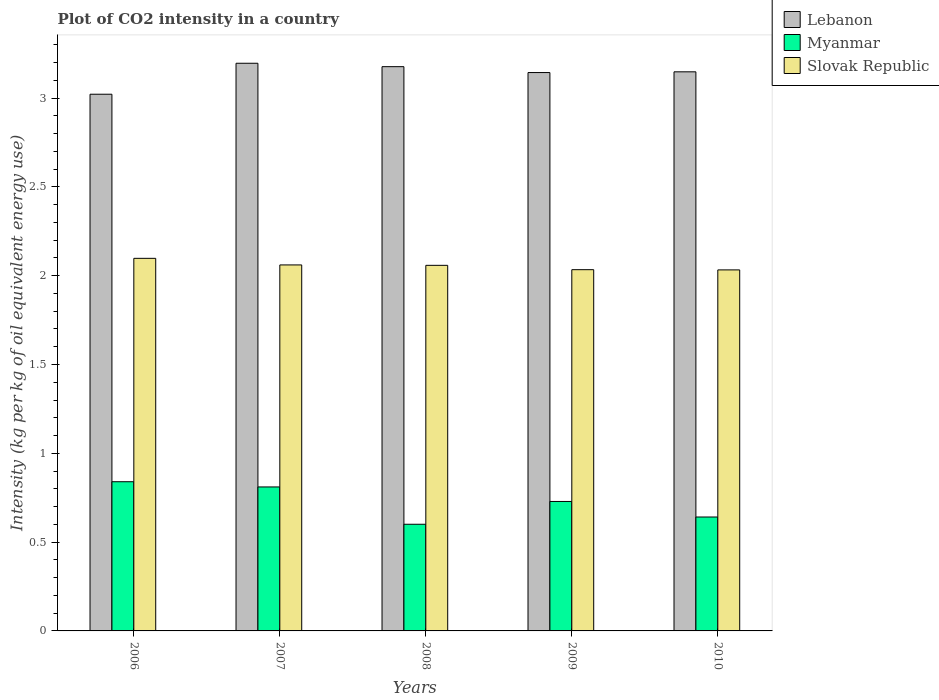How many different coloured bars are there?
Make the answer very short. 3. How many groups of bars are there?
Make the answer very short. 5. Are the number of bars per tick equal to the number of legend labels?
Offer a very short reply. Yes. How many bars are there on the 2nd tick from the left?
Ensure brevity in your answer.  3. How many bars are there on the 5th tick from the right?
Ensure brevity in your answer.  3. What is the label of the 5th group of bars from the left?
Make the answer very short. 2010. What is the CO2 intensity in in Slovak Republic in 2010?
Ensure brevity in your answer.  2.03. Across all years, what is the maximum CO2 intensity in in Slovak Republic?
Keep it short and to the point. 2.1. Across all years, what is the minimum CO2 intensity in in Slovak Republic?
Offer a very short reply. 2.03. What is the total CO2 intensity in in Slovak Republic in the graph?
Ensure brevity in your answer.  10.28. What is the difference between the CO2 intensity in in Slovak Republic in 2006 and that in 2008?
Offer a terse response. 0.04. What is the difference between the CO2 intensity in in Slovak Republic in 2008 and the CO2 intensity in in Lebanon in 2010?
Make the answer very short. -1.09. What is the average CO2 intensity in in Myanmar per year?
Make the answer very short. 0.72. In the year 2009, what is the difference between the CO2 intensity in in Myanmar and CO2 intensity in in Slovak Republic?
Make the answer very short. -1.31. What is the ratio of the CO2 intensity in in Myanmar in 2006 to that in 2008?
Ensure brevity in your answer.  1.4. Is the CO2 intensity in in Lebanon in 2006 less than that in 2009?
Give a very brief answer. Yes. Is the difference between the CO2 intensity in in Myanmar in 2009 and 2010 greater than the difference between the CO2 intensity in in Slovak Republic in 2009 and 2010?
Your answer should be very brief. Yes. What is the difference between the highest and the second highest CO2 intensity in in Lebanon?
Your answer should be very brief. 0.02. What is the difference between the highest and the lowest CO2 intensity in in Myanmar?
Make the answer very short. 0.24. In how many years, is the CO2 intensity in in Slovak Republic greater than the average CO2 intensity in in Slovak Republic taken over all years?
Your response must be concise. 3. Is the sum of the CO2 intensity in in Myanmar in 2006 and 2008 greater than the maximum CO2 intensity in in Lebanon across all years?
Your response must be concise. No. What does the 3rd bar from the left in 2006 represents?
Make the answer very short. Slovak Republic. What does the 2nd bar from the right in 2010 represents?
Your response must be concise. Myanmar. Is it the case that in every year, the sum of the CO2 intensity in in Myanmar and CO2 intensity in in Slovak Republic is greater than the CO2 intensity in in Lebanon?
Ensure brevity in your answer.  No. Are all the bars in the graph horizontal?
Offer a very short reply. No. How many years are there in the graph?
Your answer should be compact. 5. What is the difference between two consecutive major ticks on the Y-axis?
Provide a short and direct response. 0.5. How many legend labels are there?
Your response must be concise. 3. What is the title of the graph?
Ensure brevity in your answer.  Plot of CO2 intensity in a country. What is the label or title of the Y-axis?
Keep it short and to the point. Intensity (kg per kg of oil equivalent energy use). What is the Intensity (kg per kg of oil equivalent energy use) in Lebanon in 2006?
Make the answer very short. 3.02. What is the Intensity (kg per kg of oil equivalent energy use) of Myanmar in 2006?
Your response must be concise. 0.84. What is the Intensity (kg per kg of oil equivalent energy use) in Slovak Republic in 2006?
Offer a terse response. 2.1. What is the Intensity (kg per kg of oil equivalent energy use) in Lebanon in 2007?
Ensure brevity in your answer.  3.2. What is the Intensity (kg per kg of oil equivalent energy use) in Myanmar in 2007?
Offer a very short reply. 0.81. What is the Intensity (kg per kg of oil equivalent energy use) of Slovak Republic in 2007?
Offer a terse response. 2.06. What is the Intensity (kg per kg of oil equivalent energy use) of Lebanon in 2008?
Your answer should be compact. 3.18. What is the Intensity (kg per kg of oil equivalent energy use) in Myanmar in 2008?
Your response must be concise. 0.6. What is the Intensity (kg per kg of oil equivalent energy use) of Slovak Republic in 2008?
Provide a short and direct response. 2.06. What is the Intensity (kg per kg of oil equivalent energy use) of Lebanon in 2009?
Give a very brief answer. 3.14. What is the Intensity (kg per kg of oil equivalent energy use) of Myanmar in 2009?
Your response must be concise. 0.73. What is the Intensity (kg per kg of oil equivalent energy use) in Slovak Republic in 2009?
Give a very brief answer. 2.03. What is the Intensity (kg per kg of oil equivalent energy use) in Lebanon in 2010?
Provide a short and direct response. 3.15. What is the Intensity (kg per kg of oil equivalent energy use) in Myanmar in 2010?
Ensure brevity in your answer.  0.64. What is the Intensity (kg per kg of oil equivalent energy use) of Slovak Republic in 2010?
Your answer should be compact. 2.03. Across all years, what is the maximum Intensity (kg per kg of oil equivalent energy use) in Lebanon?
Ensure brevity in your answer.  3.2. Across all years, what is the maximum Intensity (kg per kg of oil equivalent energy use) in Myanmar?
Provide a succinct answer. 0.84. Across all years, what is the maximum Intensity (kg per kg of oil equivalent energy use) of Slovak Republic?
Provide a succinct answer. 2.1. Across all years, what is the minimum Intensity (kg per kg of oil equivalent energy use) of Lebanon?
Make the answer very short. 3.02. Across all years, what is the minimum Intensity (kg per kg of oil equivalent energy use) of Myanmar?
Keep it short and to the point. 0.6. Across all years, what is the minimum Intensity (kg per kg of oil equivalent energy use) in Slovak Republic?
Make the answer very short. 2.03. What is the total Intensity (kg per kg of oil equivalent energy use) in Lebanon in the graph?
Offer a very short reply. 15.69. What is the total Intensity (kg per kg of oil equivalent energy use) in Myanmar in the graph?
Offer a very short reply. 3.62. What is the total Intensity (kg per kg of oil equivalent energy use) of Slovak Republic in the graph?
Your answer should be very brief. 10.28. What is the difference between the Intensity (kg per kg of oil equivalent energy use) in Lebanon in 2006 and that in 2007?
Provide a succinct answer. -0.17. What is the difference between the Intensity (kg per kg of oil equivalent energy use) in Myanmar in 2006 and that in 2007?
Make the answer very short. 0.03. What is the difference between the Intensity (kg per kg of oil equivalent energy use) of Slovak Republic in 2006 and that in 2007?
Your answer should be very brief. 0.04. What is the difference between the Intensity (kg per kg of oil equivalent energy use) of Lebanon in 2006 and that in 2008?
Your answer should be compact. -0.16. What is the difference between the Intensity (kg per kg of oil equivalent energy use) in Myanmar in 2006 and that in 2008?
Make the answer very short. 0.24. What is the difference between the Intensity (kg per kg of oil equivalent energy use) of Slovak Republic in 2006 and that in 2008?
Offer a very short reply. 0.04. What is the difference between the Intensity (kg per kg of oil equivalent energy use) in Lebanon in 2006 and that in 2009?
Your response must be concise. -0.12. What is the difference between the Intensity (kg per kg of oil equivalent energy use) of Slovak Republic in 2006 and that in 2009?
Offer a terse response. 0.06. What is the difference between the Intensity (kg per kg of oil equivalent energy use) in Lebanon in 2006 and that in 2010?
Make the answer very short. -0.13. What is the difference between the Intensity (kg per kg of oil equivalent energy use) of Myanmar in 2006 and that in 2010?
Your response must be concise. 0.2. What is the difference between the Intensity (kg per kg of oil equivalent energy use) in Slovak Republic in 2006 and that in 2010?
Offer a very short reply. 0.07. What is the difference between the Intensity (kg per kg of oil equivalent energy use) in Lebanon in 2007 and that in 2008?
Offer a terse response. 0.02. What is the difference between the Intensity (kg per kg of oil equivalent energy use) in Myanmar in 2007 and that in 2008?
Your response must be concise. 0.21. What is the difference between the Intensity (kg per kg of oil equivalent energy use) of Slovak Republic in 2007 and that in 2008?
Make the answer very short. 0. What is the difference between the Intensity (kg per kg of oil equivalent energy use) of Lebanon in 2007 and that in 2009?
Keep it short and to the point. 0.05. What is the difference between the Intensity (kg per kg of oil equivalent energy use) of Myanmar in 2007 and that in 2009?
Make the answer very short. 0.08. What is the difference between the Intensity (kg per kg of oil equivalent energy use) of Slovak Republic in 2007 and that in 2009?
Offer a very short reply. 0.03. What is the difference between the Intensity (kg per kg of oil equivalent energy use) of Lebanon in 2007 and that in 2010?
Provide a succinct answer. 0.05. What is the difference between the Intensity (kg per kg of oil equivalent energy use) of Myanmar in 2007 and that in 2010?
Provide a succinct answer. 0.17. What is the difference between the Intensity (kg per kg of oil equivalent energy use) of Slovak Republic in 2007 and that in 2010?
Offer a very short reply. 0.03. What is the difference between the Intensity (kg per kg of oil equivalent energy use) in Lebanon in 2008 and that in 2009?
Offer a very short reply. 0.03. What is the difference between the Intensity (kg per kg of oil equivalent energy use) of Myanmar in 2008 and that in 2009?
Provide a short and direct response. -0.13. What is the difference between the Intensity (kg per kg of oil equivalent energy use) of Slovak Republic in 2008 and that in 2009?
Your response must be concise. 0.02. What is the difference between the Intensity (kg per kg of oil equivalent energy use) in Lebanon in 2008 and that in 2010?
Your answer should be very brief. 0.03. What is the difference between the Intensity (kg per kg of oil equivalent energy use) of Myanmar in 2008 and that in 2010?
Keep it short and to the point. -0.04. What is the difference between the Intensity (kg per kg of oil equivalent energy use) of Slovak Republic in 2008 and that in 2010?
Offer a very short reply. 0.03. What is the difference between the Intensity (kg per kg of oil equivalent energy use) in Lebanon in 2009 and that in 2010?
Your answer should be compact. -0. What is the difference between the Intensity (kg per kg of oil equivalent energy use) in Myanmar in 2009 and that in 2010?
Provide a short and direct response. 0.09. What is the difference between the Intensity (kg per kg of oil equivalent energy use) of Slovak Republic in 2009 and that in 2010?
Your answer should be compact. 0. What is the difference between the Intensity (kg per kg of oil equivalent energy use) of Lebanon in 2006 and the Intensity (kg per kg of oil equivalent energy use) of Myanmar in 2007?
Give a very brief answer. 2.21. What is the difference between the Intensity (kg per kg of oil equivalent energy use) of Lebanon in 2006 and the Intensity (kg per kg of oil equivalent energy use) of Slovak Republic in 2007?
Give a very brief answer. 0.96. What is the difference between the Intensity (kg per kg of oil equivalent energy use) in Myanmar in 2006 and the Intensity (kg per kg of oil equivalent energy use) in Slovak Republic in 2007?
Provide a short and direct response. -1.22. What is the difference between the Intensity (kg per kg of oil equivalent energy use) of Lebanon in 2006 and the Intensity (kg per kg of oil equivalent energy use) of Myanmar in 2008?
Your answer should be very brief. 2.42. What is the difference between the Intensity (kg per kg of oil equivalent energy use) in Lebanon in 2006 and the Intensity (kg per kg of oil equivalent energy use) in Slovak Republic in 2008?
Your response must be concise. 0.96. What is the difference between the Intensity (kg per kg of oil equivalent energy use) of Myanmar in 2006 and the Intensity (kg per kg of oil equivalent energy use) of Slovak Republic in 2008?
Your answer should be compact. -1.22. What is the difference between the Intensity (kg per kg of oil equivalent energy use) of Lebanon in 2006 and the Intensity (kg per kg of oil equivalent energy use) of Myanmar in 2009?
Your answer should be very brief. 2.29. What is the difference between the Intensity (kg per kg of oil equivalent energy use) in Lebanon in 2006 and the Intensity (kg per kg of oil equivalent energy use) in Slovak Republic in 2009?
Your response must be concise. 0.99. What is the difference between the Intensity (kg per kg of oil equivalent energy use) in Myanmar in 2006 and the Intensity (kg per kg of oil equivalent energy use) in Slovak Republic in 2009?
Offer a very short reply. -1.19. What is the difference between the Intensity (kg per kg of oil equivalent energy use) in Lebanon in 2006 and the Intensity (kg per kg of oil equivalent energy use) in Myanmar in 2010?
Make the answer very short. 2.38. What is the difference between the Intensity (kg per kg of oil equivalent energy use) in Myanmar in 2006 and the Intensity (kg per kg of oil equivalent energy use) in Slovak Republic in 2010?
Provide a short and direct response. -1.19. What is the difference between the Intensity (kg per kg of oil equivalent energy use) of Lebanon in 2007 and the Intensity (kg per kg of oil equivalent energy use) of Myanmar in 2008?
Offer a very short reply. 2.6. What is the difference between the Intensity (kg per kg of oil equivalent energy use) in Lebanon in 2007 and the Intensity (kg per kg of oil equivalent energy use) in Slovak Republic in 2008?
Make the answer very short. 1.14. What is the difference between the Intensity (kg per kg of oil equivalent energy use) of Myanmar in 2007 and the Intensity (kg per kg of oil equivalent energy use) of Slovak Republic in 2008?
Ensure brevity in your answer.  -1.25. What is the difference between the Intensity (kg per kg of oil equivalent energy use) in Lebanon in 2007 and the Intensity (kg per kg of oil equivalent energy use) in Myanmar in 2009?
Offer a terse response. 2.47. What is the difference between the Intensity (kg per kg of oil equivalent energy use) of Lebanon in 2007 and the Intensity (kg per kg of oil equivalent energy use) of Slovak Republic in 2009?
Provide a short and direct response. 1.16. What is the difference between the Intensity (kg per kg of oil equivalent energy use) of Myanmar in 2007 and the Intensity (kg per kg of oil equivalent energy use) of Slovak Republic in 2009?
Give a very brief answer. -1.22. What is the difference between the Intensity (kg per kg of oil equivalent energy use) of Lebanon in 2007 and the Intensity (kg per kg of oil equivalent energy use) of Myanmar in 2010?
Provide a short and direct response. 2.55. What is the difference between the Intensity (kg per kg of oil equivalent energy use) in Lebanon in 2007 and the Intensity (kg per kg of oil equivalent energy use) in Slovak Republic in 2010?
Your answer should be very brief. 1.16. What is the difference between the Intensity (kg per kg of oil equivalent energy use) of Myanmar in 2007 and the Intensity (kg per kg of oil equivalent energy use) of Slovak Republic in 2010?
Provide a succinct answer. -1.22. What is the difference between the Intensity (kg per kg of oil equivalent energy use) of Lebanon in 2008 and the Intensity (kg per kg of oil equivalent energy use) of Myanmar in 2009?
Offer a terse response. 2.45. What is the difference between the Intensity (kg per kg of oil equivalent energy use) of Lebanon in 2008 and the Intensity (kg per kg of oil equivalent energy use) of Slovak Republic in 2009?
Keep it short and to the point. 1.14. What is the difference between the Intensity (kg per kg of oil equivalent energy use) of Myanmar in 2008 and the Intensity (kg per kg of oil equivalent energy use) of Slovak Republic in 2009?
Provide a short and direct response. -1.43. What is the difference between the Intensity (kg per kg of oil equivalent energy use) of Lebanon in 2008 and the Intensity (kg per kg of oil equivalent energy use) of Myanmar in 2010?
Your answer should be compact. 2.54. What is the difference between the Intensity (kg per kg of oil equivalent energy use) of Lebanon in 2008 and the Intensity (kg per kg of oil equivalent energy use) of Slovak Republic in 2010?
Make the answer very short. 1.14. What is the difference between the Intensity (kg per kg of oil equivalent energy use) in Myanmar in 2008 and the Intensity (kg per kg of oil equivalent energy use) in Slovak Republic in 2010?
Your answer should be compact. -1.43. What is the difference between the Intensity (kg per kg of oil equivalent energy use) in Lebanon in 2009 and the Intensity (kg per kg of oil equivalent energy use) in Myanmar in 2010?
Offer a very short reply. 2.5. What is the difference between the Intensity (kg per kg of oil equivalent energy use) in Lebanon in 2009 and the Intensity (kg per kg of oil equivalent energy use) in Slovak Republic in 2010?
Your response must be concise. 1.11. What is the difference between the Intensity (kg per kg of oil equivalent energy use) in Myanmar in 2009 and the Intensity (kg per kg of oil equivalent energy use) in Slovak Republic in 2010?
Ensure brevity in your answer.  -1.3. What is the average Intensity (kg per kg of oil equivalent energy use) in Lebanon per year?
Keep it short and to the point. 3.14. What is the average Intensity (kg per kg of oil equivalent energy use) in Myanmar per year?
Make the answer very short. 0.72. What is the average Intensity (kg per kg of oil equivalent energy use) in Slovak Republic per year?
Keep it short and to the point. 2.06. In the year 2006, what is the difference between the Intensity (kg per kg of oil equivalent energy use) in Lebanon and Intensity (kg per kg of oil equivalent energy use) in Myanmar?
Your answer should be very brief. 2.18. In the year 2006, what is the difference between the Intensity (kg per kg of oil equivalent energy use) in Lebanon and Intensity (kg per kg of oil equivalent energy use) in Slovak Republic?
Offer a very short reply. 0.92. In the year 2006, what is the difference between the Intensity (kg per kg of oil equivalent energy use) of Myanmar and Intensity (kg per kg of oil equivalent energy use) of Slovak Republic?
Offer a terse response. -1.26. In the year 2007, what is the difference between the Intensity (kg per kg of oil equivalent energy use) in Lebanon and Intensity (kg per kg of oil equivalent energy use) in Myanmar?
Give a very brief answer. 2.39. In the year 2007, what is the difference between the Intensity (kg per kg of oil equivalent energy use) in Lebanon and Intensity (kg per kg of oil equivalent energy use) in Slovak Republic?
Keep it short and to the point. 1.14. In the year 2007, what is the difference between the Intensity (kg per kg of oil equivalent energy use) of Myanmar and Intensity (kg per kg of oil equivalent energy use) of Slovak Republic?
Your answer should be very brief. -1.25. In the year 2008, what is the difference between the Intensity (kg per kg of oil equivalent energy use) in Lebanon and Intensity (kg per kg of oil equivalent energy use) in Myanmar?
Provide a short and direct response. 2.58. In the year 2008, what is the difference between the Intensity (kg per kg of oil equivalent energy use) of Lebanon and Intensity (kg per kg of oil equivalent energy use) of Slovak Republic?
Offer a very short reply. 1.12. In the year 2008, what is the difference between the Intensity (kg per kg of oil equivalent energy use) of Myanmar and Intensity (kg per kg of oil equivalent energy use) of Slovak Republic?
Make the answer very short. -1.46. In the year 2009, what is the difference between the Intensity (kg per kg of oil equivalent energy use) in Lebanon and Intensity (kg per kg of oil equivalent energy use) in Myanmar?
Your answer should be very brief. 2.41. In the year 2009, what is the difference between the Intensity (kg per kg of oil equivalent energy use) in Lebanon and Intensity (kg per kg of oil equivalent energy use) in Slovak Republic?
Offer a very short reply. 1.11. In the year 2009, what is the difference between the Intensity (kg per kg of oil equivalent energy use) of Myanmar and Intensity (kg per kg of oil equivalent energy use) of Slovak Republic?
Keep it short and to the point. -1.31. In the year 2010, what is the difference between the Intensity (kg per kg of oil equivalent energy use) of Lebanon and Intensity (kg per kg of oil equivalent energy use) of Myanmar?
Make the answer very short. 2.51. In the year 2010, what is the difference between the Intensity (kg per kg of oil equivalent energy use) of Lebanon and Intensity (kg per kg of oil equivalent energy use) of Slovak Republic?
Provide a succinct answer. 1.12. In the year 2010, what is the difference between the Intensity (kg per kg of oil equivalent energy use) of Myanmar and Intensity (kg per kg of oil equivalent energy use) of Slovak Republic?
Ensure brevity in your answer.  -1.39. What is the ratio of the Intensity (kg per kg of oil equivalent energy use) in Lebanon in 2006 to that in 2007?
Offer a terse response. 0.95. What is the ratio of the Intensity (kg per kg of oil equivalent energy use) in Myanmar in 2006 to that in 2007?
Ensure brevity in your answer.  1.04. What is the ratio of the Intensity (kg per kg of oil equivalent energy use) in Slovak Republic in 2006 to that in 2007?
Offer a terse response. 1.02. What is the ratio of the Intensity (kg per kg of oil equivalent energy use) in Lebanon in 2006 to that in 2008?
Provide a short and direct response. 0.95. What is the ratio of the Intensity (kg per kg of oil equivalent energy use) in Myanmar in 2006 to that in 2008?
Offer a terse response. 1.4. What is the ratio of the Intensity (kg per kg of oil equivalent energy use) of Slovak Republic in 2006 to that in 2008?
Ensure brevity in your answer.  1.02. What is the ratio of the Intensity (kg per kg of oil equivalent energy use) in Lebanon in 2006 to that in 2009?
Your response must be concise. 0.96. What is the ratio of the Intensity (kg per kg of oil equivalent energy use) of Myanmar in 2006 to that in 2009?
Your answer should be very brief. 1.15. What is the ratio of the Intensity (kg per kg of oil equivalent energy use) of Slovak Republic in 2006 to that in 2009?
Provide a succinct answer. 1.03. What is the ratio of the Intensity (kg per kg of oil equivalent energy use) of Lebanon in 2006 to that in 2010?
Offer a very short reply. 0.96. What is the ratio of the Intensity (kg per kg of oil equivalent energy use) of Myanmar in 2006 to that in 2010?
Offer a terse response. 1.31. What is the ratio of the Intensity (kg per kg of oil equivalent energy use) in Slovak Republic in 2006 to that in 2010?
Provide a short and direct response. 1.03. What is the ratio of the Intensity (kg per kg of oil equivalent energy use) of Lebanon in 2007 to that in 2008?
Give a very brief answer. 1.01. What is the ratio of the Intensity (kg per kg of oil equivalent energy use) in Myanmar in 2007 to that in 2008?
Give a very brief answer. 1.35. What is the ratio of the Intensity (kg per kg of oil equivalent energy use) in Slovak Republic in 2007 to that in 2008?
Make the answer very short. 1. What is the ratio of the Intensity (kg per kg of oil equivalent energy use) in Lebanon in 2007 to that in 2009?
Your answer should be very brief. 1.02. What is the ratio of the Intensity (kg per kg of oil equivalent energy use) of Myanmar in 2007 to that in 2009?
Provide a short and direct response. 1.11. What is the ratio of the Intensity (kg per kg of oil equivalent energy use) of Slovak Republic in 2007 to that in 2009?
Your answer should be compact. 1.01. What is the ratio of the Intensity (kg per kg of oil equivalent energy use) of Lebanon in 2007 to that in 2010?
Provide a succinct answer. 1.02. What is the ratio of the Intensity (kg per kg of oil equivalent energy use) of Myanmar in 2007 to that in 2010?
Make the answer very short. 1.26. What is the ratio of the Intensity (kg per kg of oil equivalent energy use) in Slovak Republic in 2007 to that in 2010?
Offer a terse response. 1.01. What is the ratio of the Intensity (kg per kg of oil equivalent energy use) of Lebanon in 2008 to that in 2009?
Keep it short and to the point. 1.01. What is the ratio of the Intensity (kg per kg of oil equivalent energy use) in Myanmar in 2008 to that in 2009?
Your answer should be compact. 0.82. What is the ratio of the Intensity (kg per kg of oil equivalent energy use) in Slovak Republic in 2008 to that in 2009?
Provide a short and direct response. 1.01. What is the ratio of the Intensity (kg per kg of oil equivalent energy use) in Lebanon in 2008 to that in 2010?
Your answer should be compact. 1.01. What is the ratio of the Intensity (kg per kg of oil equivalent energy use) in Myanmar in 2008 to that in 2010?
Give a very brief answer. 0.94. What is the ratio of the Intensity (kg per kg of oil equivalent energy use) of Slovak Republic in 2008 to that in 2010?
Your answer should be compact. 1.01. What is the ratio of the Intensity (kg per kg of oil equivalent energy use) of Myanmar in 2009 to that in 2010?
Your answer should be compact. 1.14. What is the ratio of the Intensity (kg per kg of oil equivalent energy use) in Slovak Republic in 2009 to that in 2010?
Ensure brevity in your answer.  1. What is the difference between the highest and the second highest Intensity (kg per kg of oil equivalent energy use) in Lebanon?
Your answer should be very brief. 0.02. What is the difference between the highest and the second highest Intensity (kg per kg of oil equivalent energy use) of Myanmar?
Your answer should be compact. 0.03. What is the difference between the highest and the second highest Intensity (kg per kg of oil equivalent energy use) of Slovak Republic?
Your answer should be very brief. 0.04. What is the difference between the highest and the lowest Intensity (kg per kg of oil equivalent energy use) of Lebanon?
Give a very brief answer. 0.17. What is the difference between the highest and the lowest Intensity (kg per kg of oil equivalent energy use) of Myanmar?
Your answer should be compact. 0.24. What is the difference between the highest and the lowest Intensity (kg per kg of oil equivalent energy use) in Slovak Republic?
Keep it short and to the point. 0.07. 